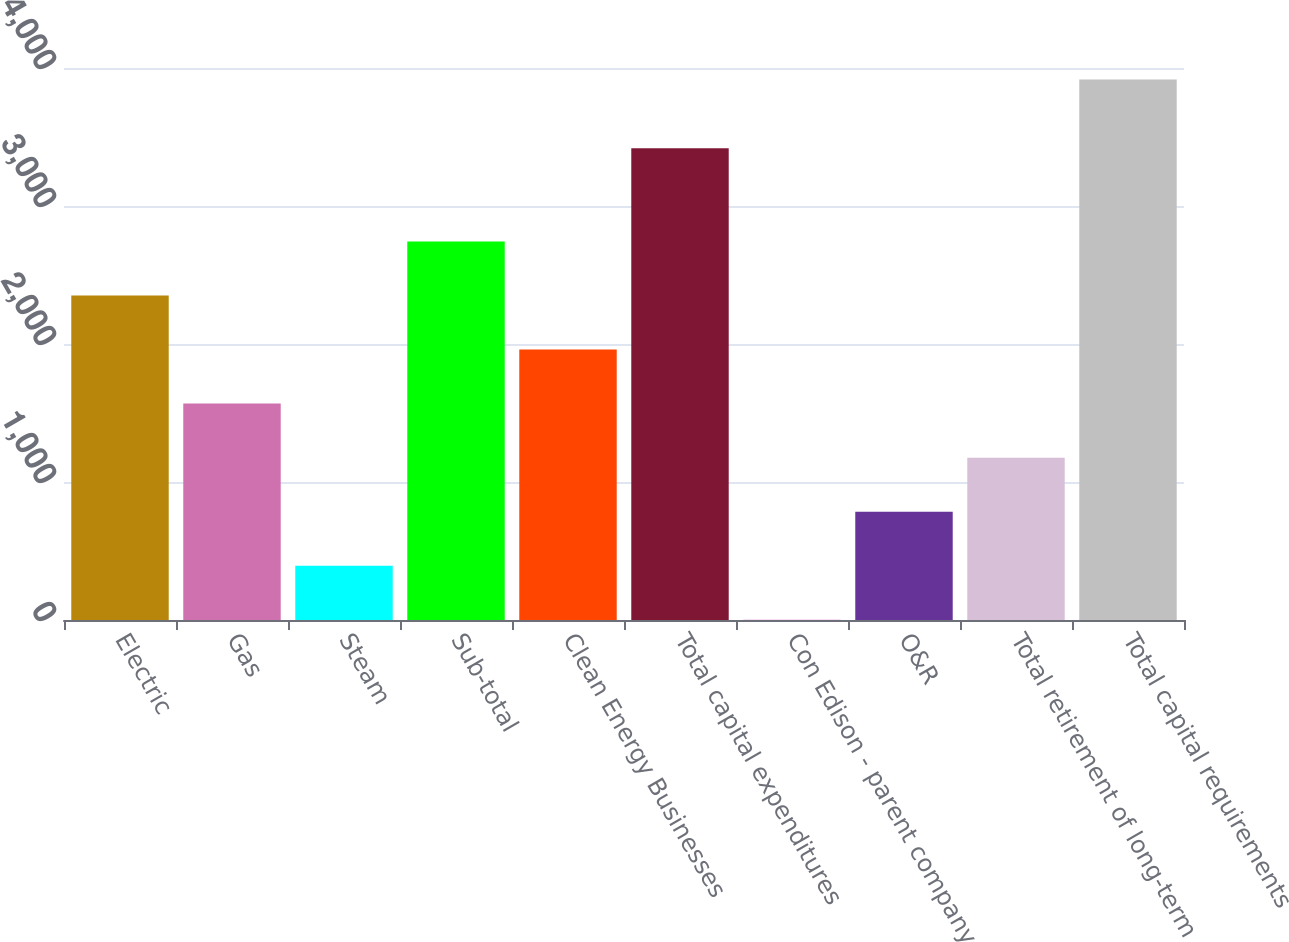Convert chart. <chart><loc_0><loc_0><loc_500><loc_500><bar_chart><fcel>Electric<fcel>Gas<fcel>Steam<fcel>Sub-total<fcel>Clean Energy Businesses<fcel>Total capital expenditures<fcel>Con Edison - parent company<fcel>O&R<fcel>Total retirement of long-term<fcel>Total capital requirements<nl><fcel>2351<fcel>1568<fcel>393.5<fcel>2742.5<fcel>1959.5<fcel>3418<fcel>2<fcel>785<fcel>1176.5<fcel>3917<nl></chart> 